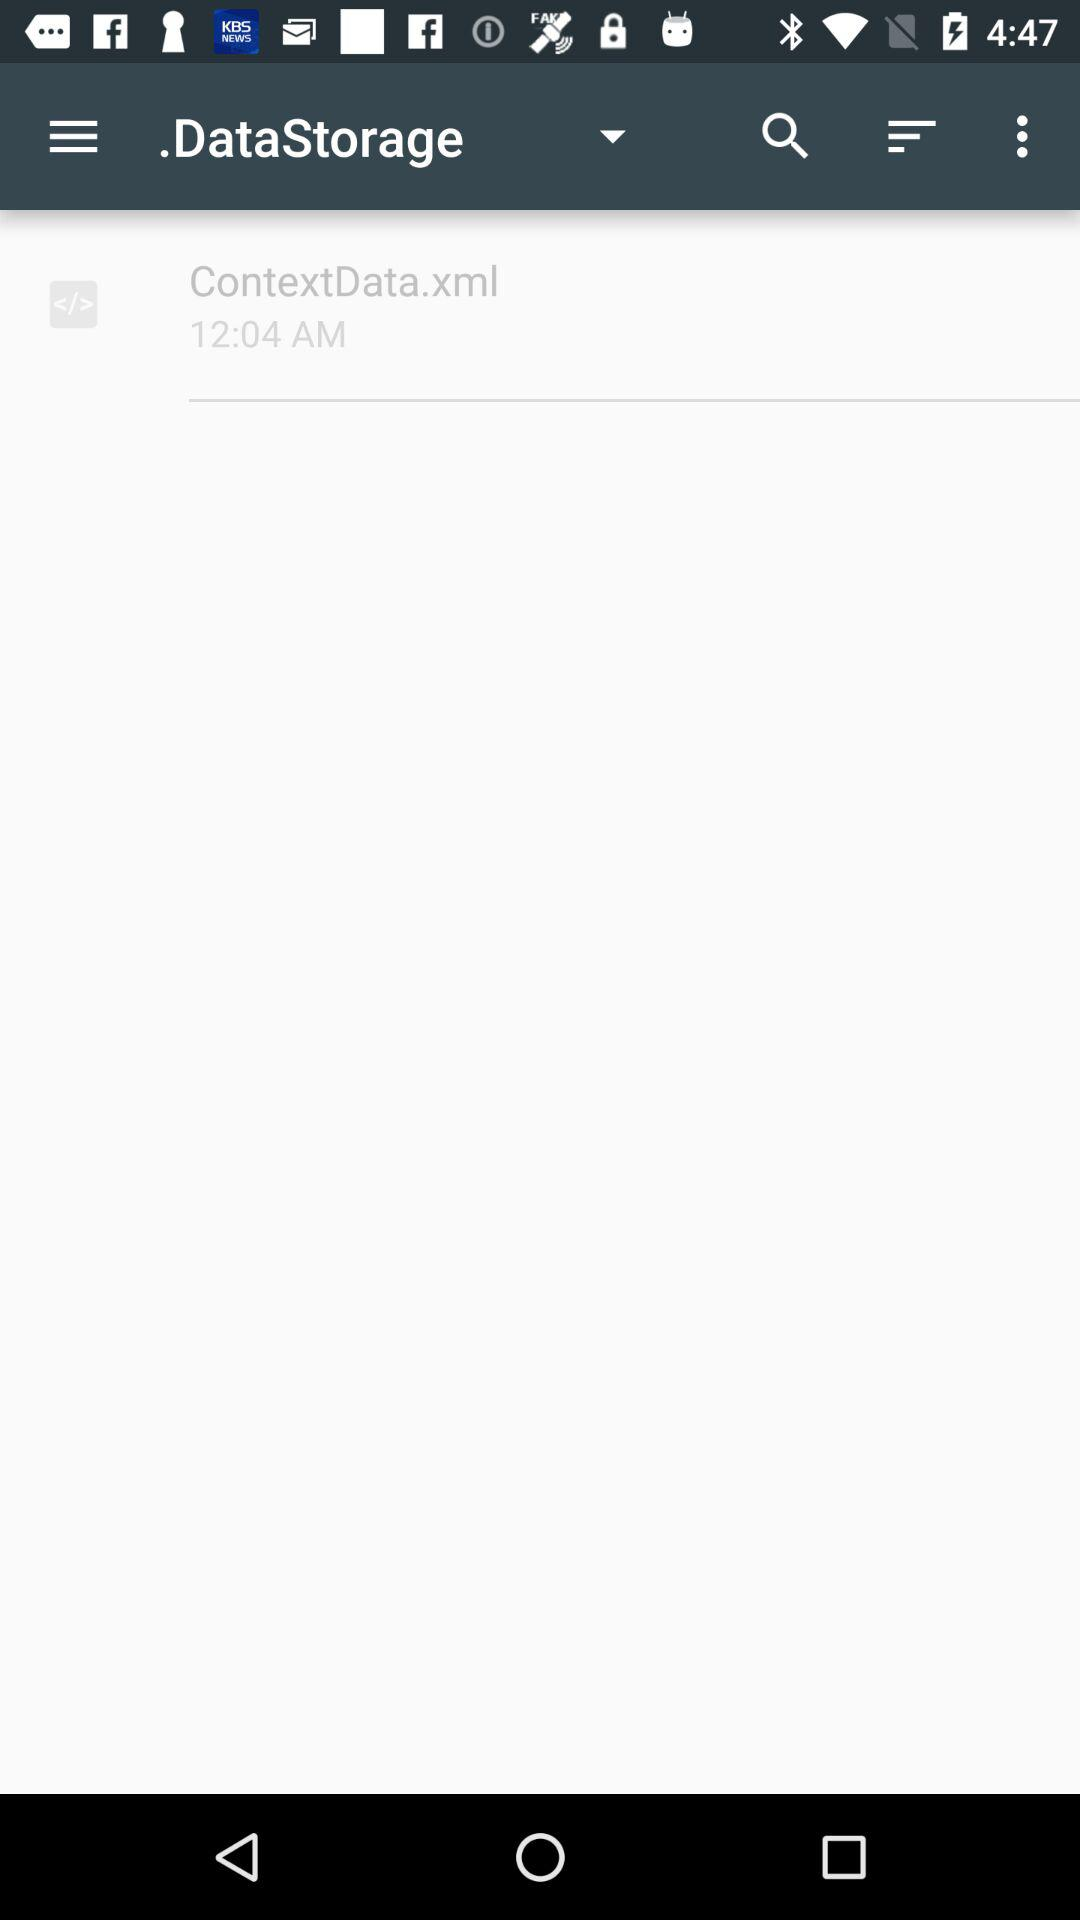What is the mentioned time? The mentioned time is 12:04 a.m. 